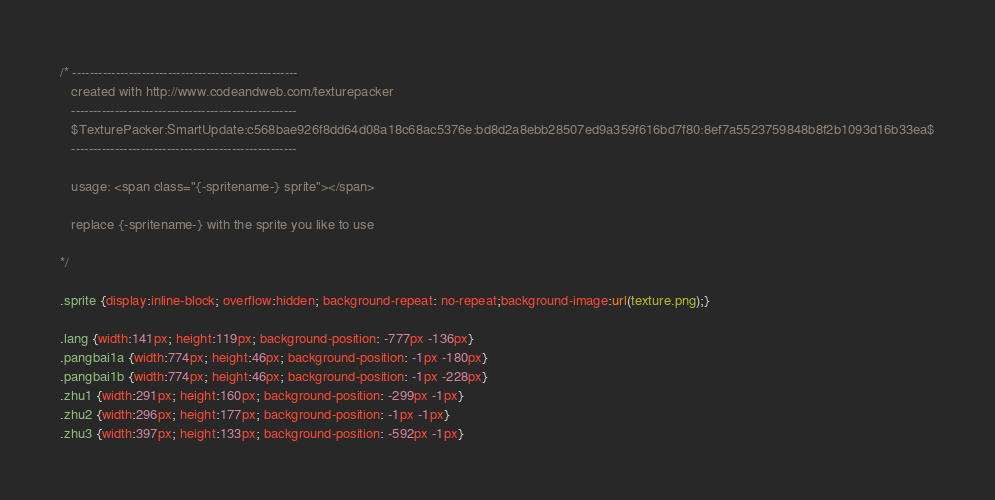<code> <loc_0><loc_0><loc_500><loc_500><_CSS_>/* ----------------------------------------------------
   created with http://www.codeandweb.com/texturepacker 
   ----------------------------------------------------
   $TexturePacker:SmartUpdate:c568bae926f8dd64d08a18c68ac5376e:bd8d2a8ebb28507ed9a359f616bd7f80:8ef7a5523759848b8f2b1093d16b33ea$
   ----------------------------------------------------

   usage: <span class="{-spritename-} sprite"></span>

   replace {-spritename-} with the sprite you like to use

*/

.sprite {display:inline-block; overflow:hidden; background-repeat: no-repeat;background-image:url(texture.png);}

.lang {width:141px; height:119px; background-position: -777px -136px}
.pangbai1a {width:774px; height:46px; background-position: -1px -180px}
.pangbai1b {width:774px; height:46px; background-position: -1px -228px}
.zhu1 {width:291px; height:160px; background-position: -299px -1px}
.zhu2 {width:296px; height:177px; background-position: -1px -1px}
.zhu3 {width:397px; height:133px; background-position: -592px -1px}
</code> 